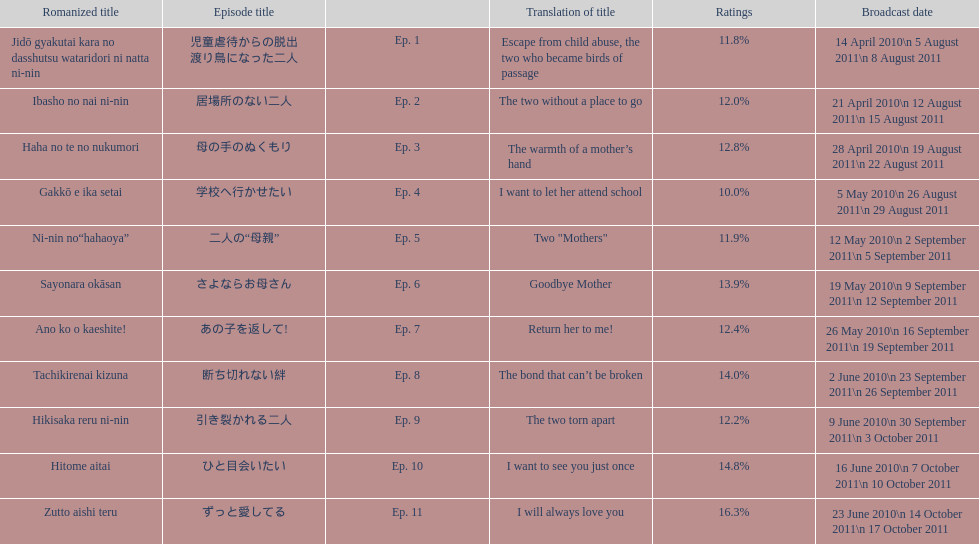What is the name of epsiode 8? 断ち切れない絆. What were this episodes ratings? 14.0%. 